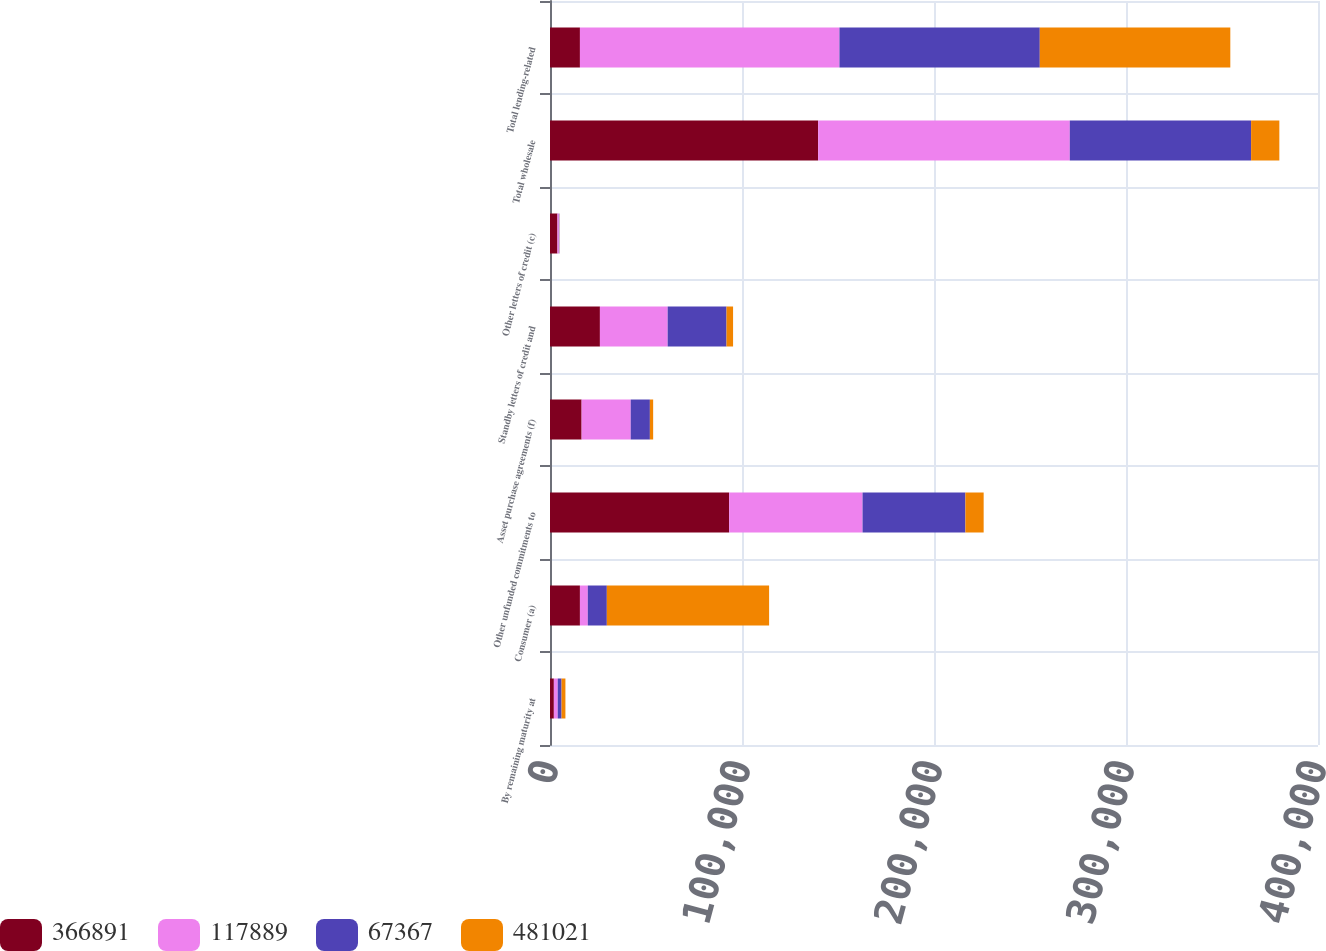Convert chart. <chart><loc_0><loc_0><loc_500><loc_500><stacked_bar_chart><ecel><fcel>By remaining maturity at<fcel>Consumer (a)<fcel>Other unfunded commitments to<fcel>Asset purchase agreements (f)<fcel>Standby letters of credit and<fcel>Other letters of credit (c)<fcel>Total wholesale<fcel>Total lending-related<nl><fcel>366891<fcel>2008<fcel>15589<fcel>93307<fcel>16467<fcel>25998<fcel>3889<fcel>139661<fcel>15589<nl><fcel>117889<fcel>2008<fcel>4098<fcel>69479<fcel>25574<fcel>35288<fcel>718<fcel>131059<fcel>135157<nl><fcel>67367<fcel>2008<fcel>9916<fcel>53567<fcel>9983<fcel>30650<fcel>240<fcel>94440<fcel>104356<nl><fcel>481021<fcel>2008<fcel>84515<fcel>9510<fcel>1705<fcel>3416<fcel>80<fcel>14711<fcel>99226<nl></chart> 